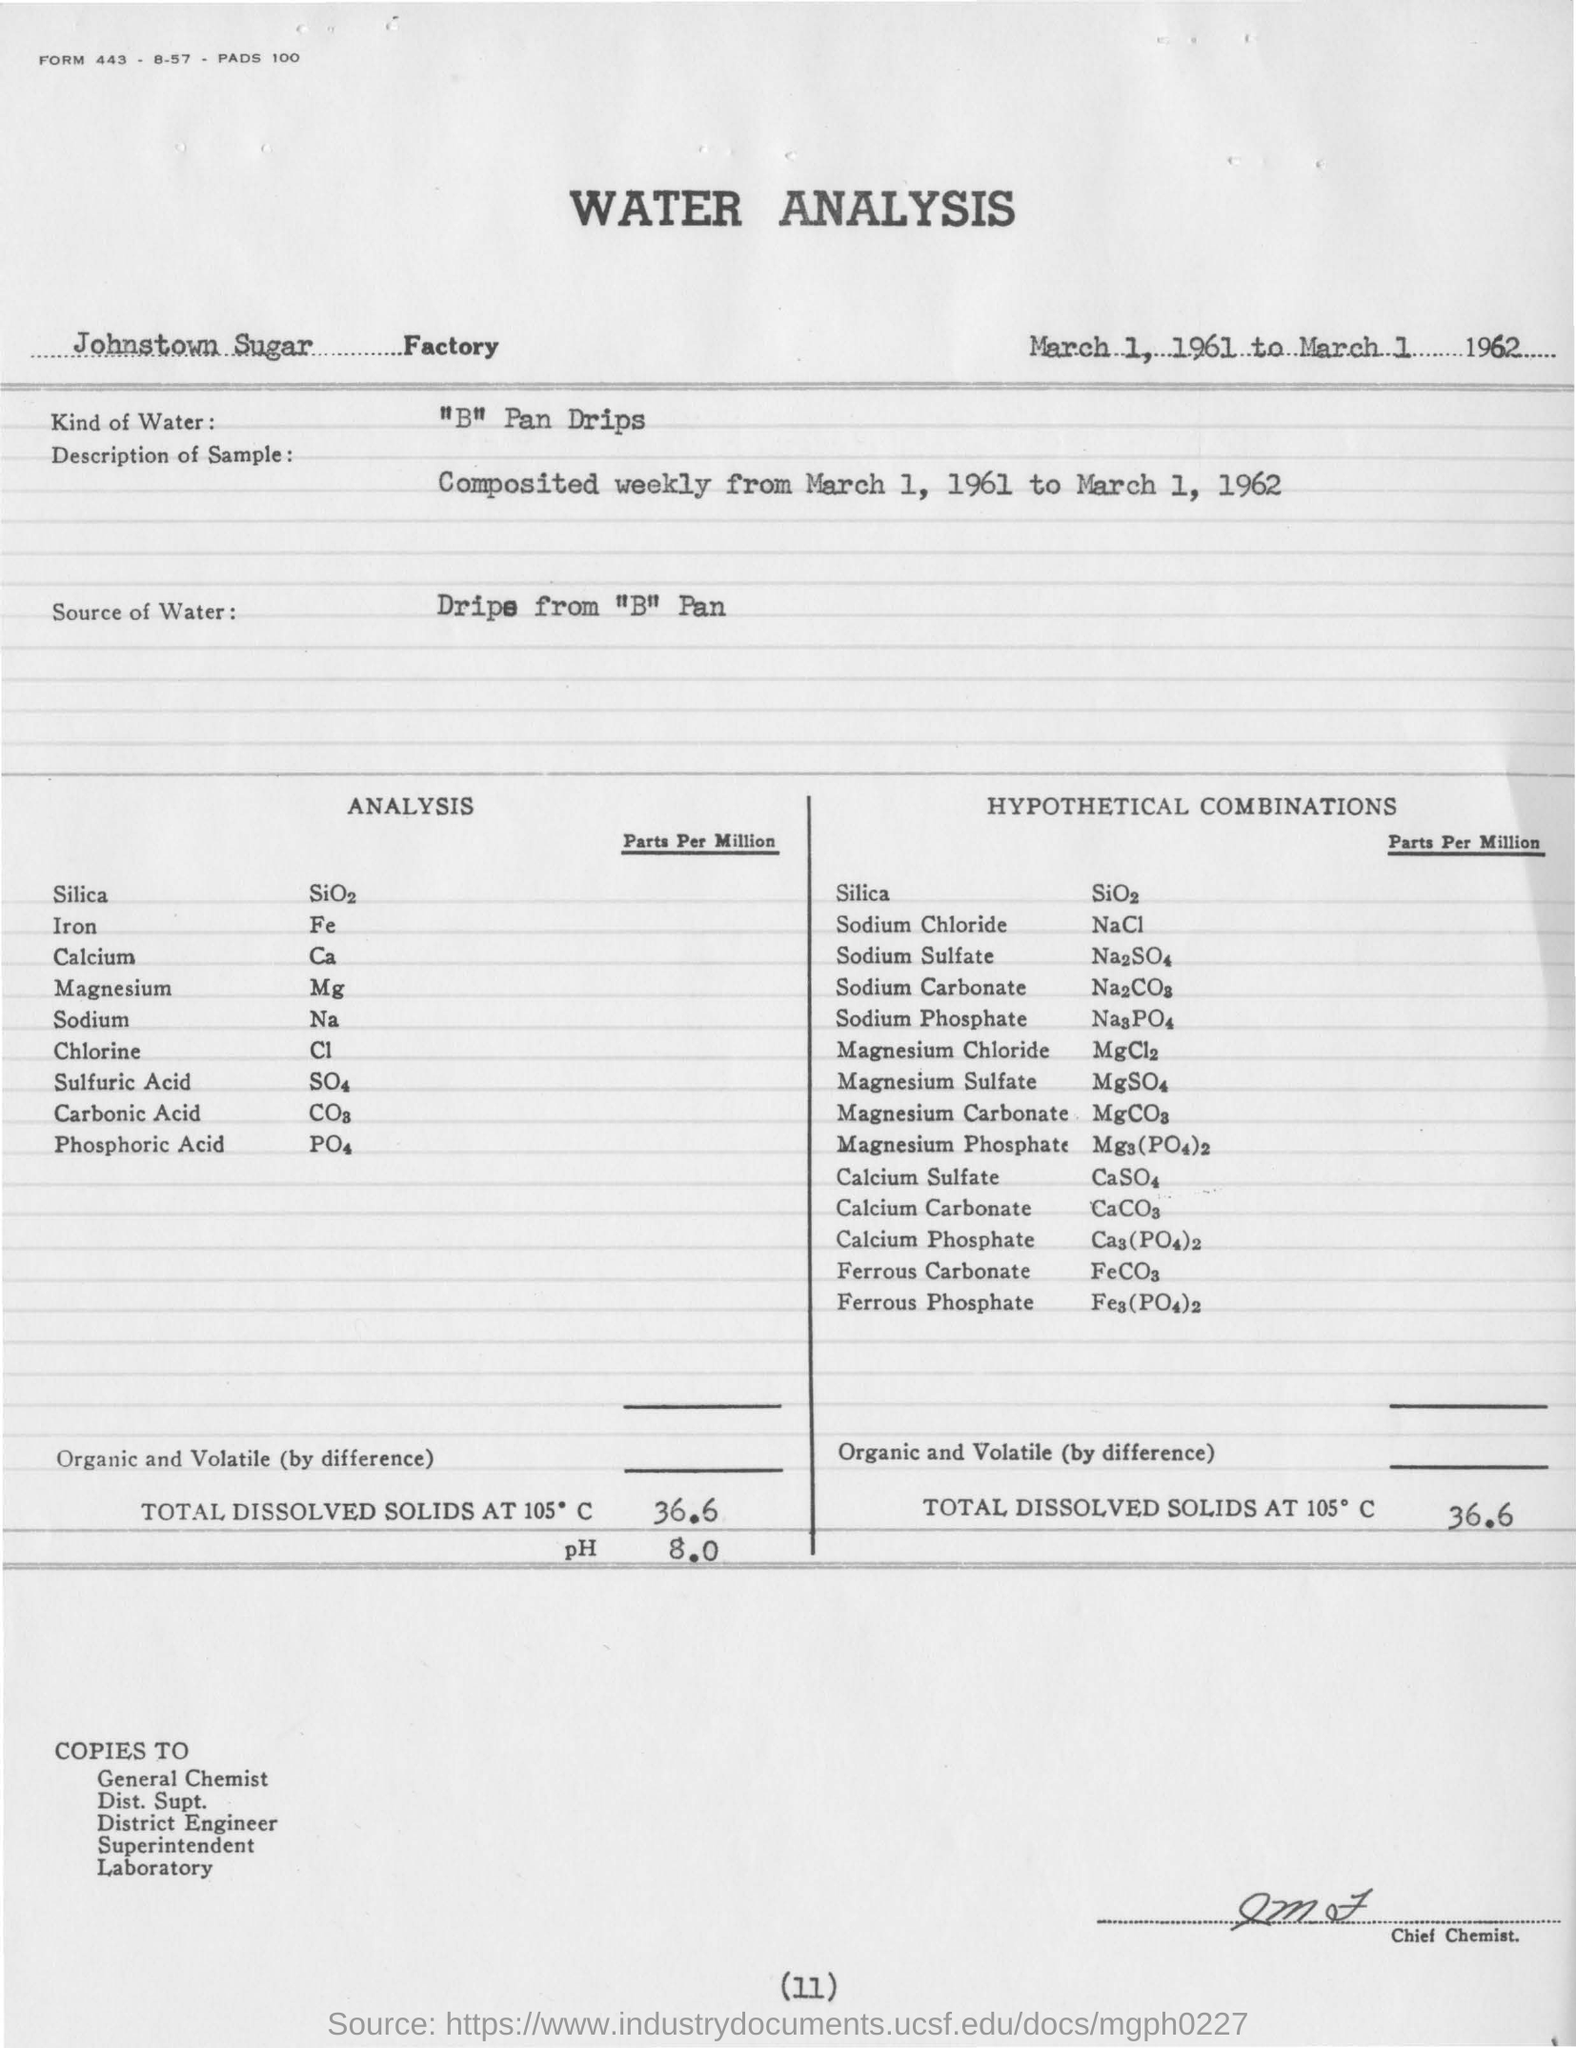What is the pH value?
Your response must be concise. 8.0. What kind of water is used in water analysis?
Give a very brief answer. "B" Pan Drips. How long are the samples collected?
Your answer should be compact. Composited weekly from March 1, 1961 to March 1, 1962. 